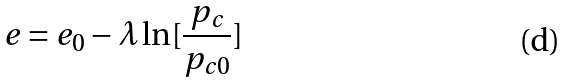<formula> <loc_0><loc_0><loc_500><loc_500>e = e _ { 0 } - \lambda \ln [ \frac { p _ { c } } { p _ { c 0 } } ]</formula> 